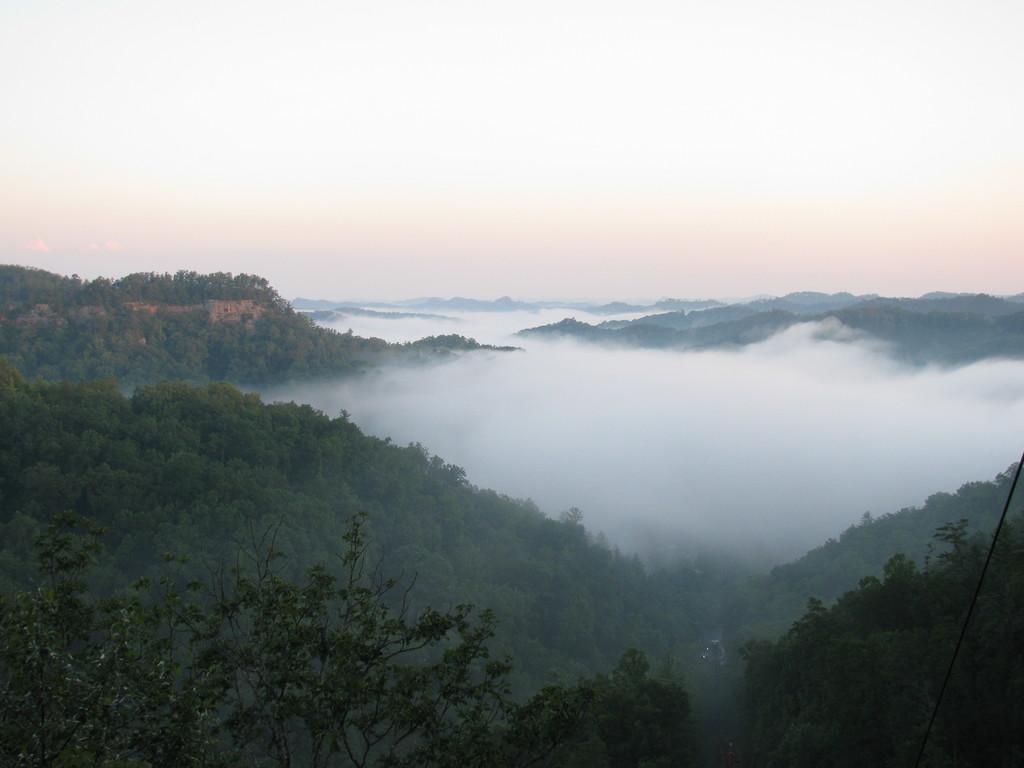How would you summarize this image in a sentence or two? In the background we can see the sky. In this picture we can see the hills and the thicket. We can see the smoke. At the bottom portion of the picture we can see the trees. In the bottom right corner of the picture we can see a black wire. 